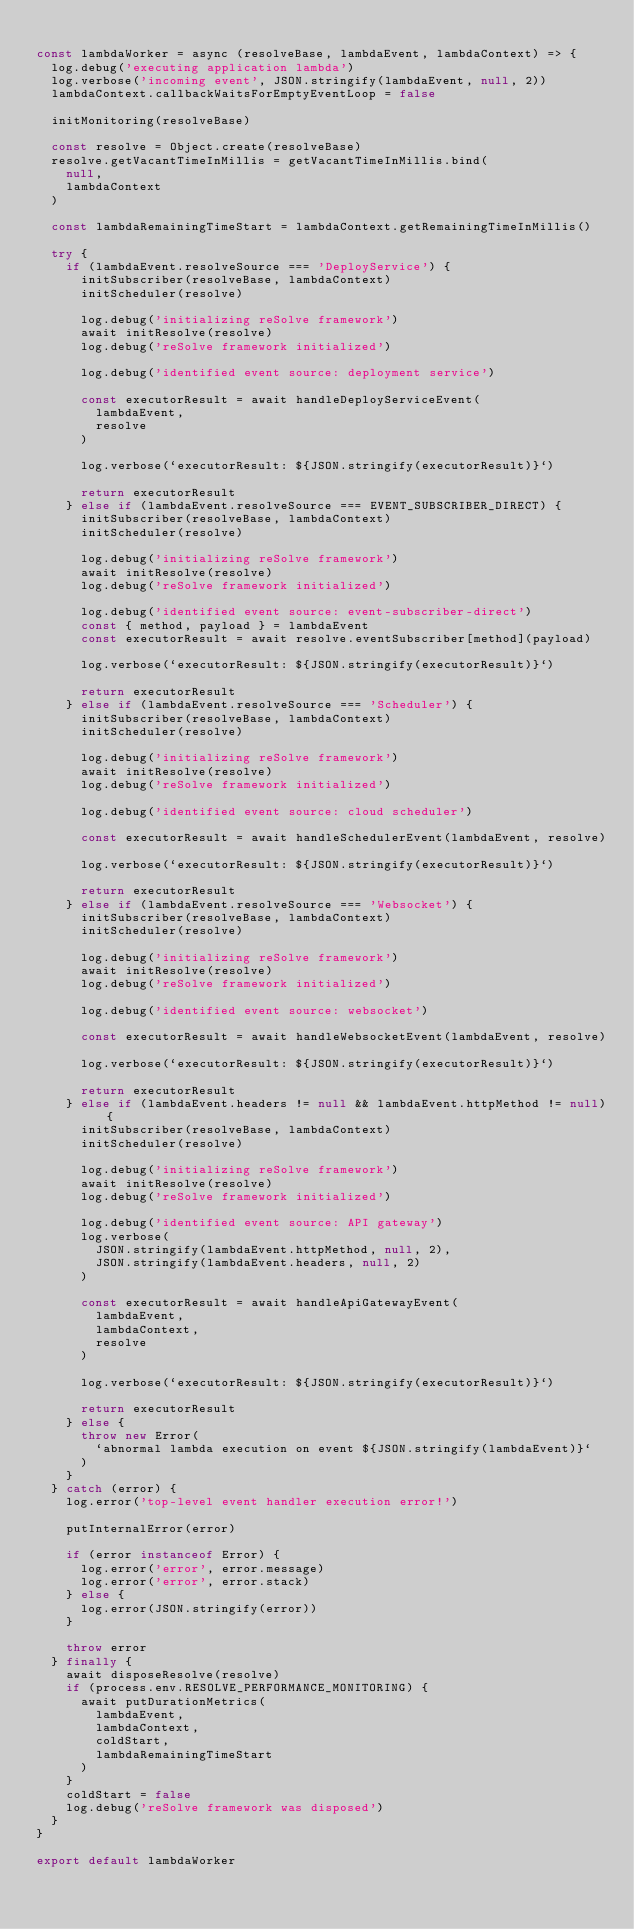Convert code to text. <code><loc_0><loc_0><loc_500><loc_500><_JavaScript_>
const lambdaWorker = async (resolveBase, lambdaEvent, lambdaContext) => {
  log.debug('executing application lambda')
  log.verbose('incoming event', JSON.stringify(lambdaEvent, null, 2))
  lambdaContext.callbackWaitsForEmptyEventLoop = false

  initMonitoring(resolveBase)

  const resolve = Object.create(resolveBase)
  resolve.getVacantTimeInMillis = getVacantTimeInMillis.bind(
    null,
    lambdaContext
  )

  const lambdaRemainingTimeStart = lambdaContext.getRemainingTimeInMillis()

  try {
    if (lambdaEvent.resolveSource === 'DeployService') {
      initSubscriber(resolveBase, lambdaContext)
      initScheduler(resolve)

      log.debug('initializing reSolve framework')
      await initResolve(resolve)
      log.debug('reSolve framework initialized')

      log.debug('identified event source: deployment service')

      const executorResult = await handleDeployServiceEvent(
        lambdaEvent,
        resolve
      )

      log.verbose(`executorResult: ${JSON.stringify(executorResult)}`)

      return executorResult
    } else if (lambdaEvent.resolveSource === EVENT_SUBSCRIBER_DIRECT) {
      initSubscriber(resolveBase, lambdaContext)
      initScheduler(resolve)

      log.debug('initializing reSolve framework')
      await initResolve(resolve)
      log.debug('reSolve framework initialized')

      log.debug('identified event source: event-subscriber-direct')
      const { method, payload } = lambdaEvent
      const executorResult = await resolve.eventSubscriber[method](payload)

      log.verbose(`executorResult: ${JSON.stringify(executorResult)}`)

      return executorResult
    } else if (lambdaEvent.resolveSource === 'Scheduler') {
      initSubscriber(resolveBase, lambdaContext)
      initScheduler(resolve)

      log.debug('initializing reSolve framework')
      await initResolve(resolve)
      log.debug('reSolve framework initialized')

      log.debug('identified event source: cloud scheduler')

      const executorResult = await handleSchedulerEvent(lambdaEvent, resolve)

      log.verbose(`executorResult: ${JSON.stringify(executorResult)}`)

      return executorResult
    } else if (lambdaEvent.resolveSource === 'Websocket') {
      initSubscriber(resolveBase, lambdaContext)
      initScheduler(resolve)

      log.debug('initializing reSolve framework')
      await initResolve(resolve)
      log.debug('reSolve framework initialized')

      log.debug('identified event source: websocket')

      const executorResult = await handleWebsocketEvent(lambdaEvent, resolve)

      log.verbose(`executorResult: ${JSON.stringify(executorResult)}`)

      return executorResult
    } else if (lambdaEvent.headers != null && lambdaEvent.httpMethod != null) {
      initSubscriber(resolveBase, lambdaContext)
      initScheduler(resolve)

      log.debug('initializing reSolve framework')
      await initResolve(resolve)
      log.debug('reSolve framework initialized')

      log.debug('identified event source: API gateway')
      log.verbose(
        JSON.stringify(lambdaEvent.httpMethod, null, 2),
        JSON.stringify(lambdaEvent.headers, null, 2)
      )

      const executorResult = await handleApiGatewayEvent(
        lambdaEvent,
        lambdaContext,
        resolve
      )

      log.verbose(`executorResult: ${JSON.stringify(executorResult)}`)

      return executorResult
    } else {
      throw new Error(
        `abnormal lambda execution on event ${JSON.stringify(lambdaEvent)}`
      )
    }
  } catch (error) {
    log.error('top-level event handler execution error!')

    putInternalError(error)

    if (error instanceof Error) {
      log.error('error', error.message)
      log.error('error', error.stack)
    } else {
      log.error(JSON.stringify(error))
    }

    throw error
  } finally {
    await disposeResolve(resolve)
    if (process.env.RESOLVE_PERFORMANCE_MONITORING) {
      await putDurationMetrics(
        lambdaEvent,
        lambdaContext,
        coldStart,
        lambdaRemainingTimeStart
      )
    }
    coldStart = false
    log.debug('reSolve framework was disposed')
  }
}

export default lambdaWorker
</code> 